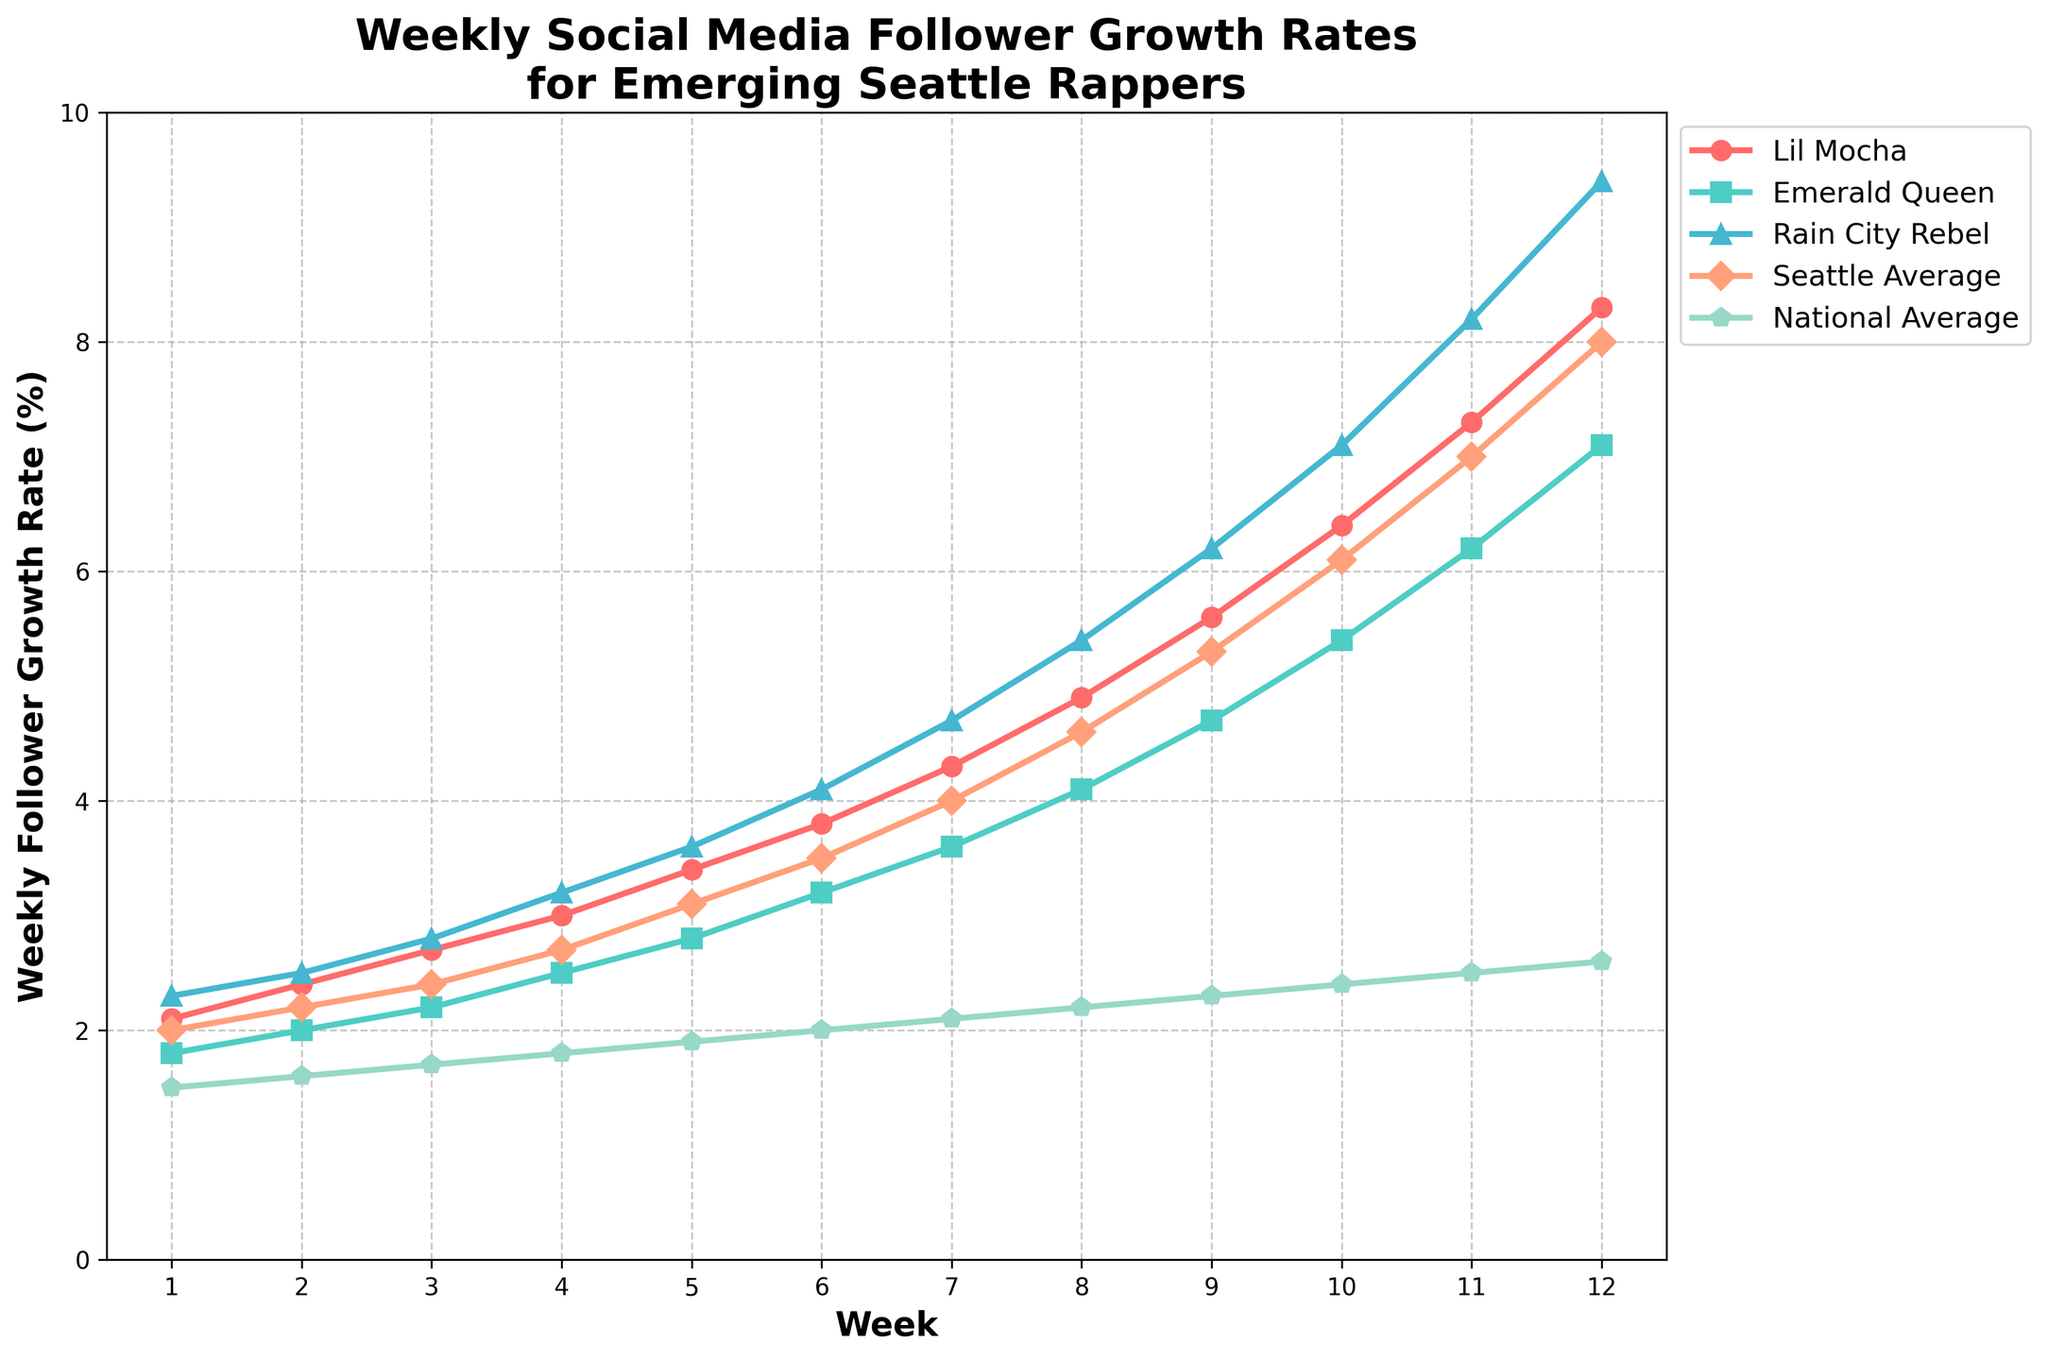How does the weekly follower growth rate of Lil Mocha compare to the Seattle Average in week 5? To answer this, locate week 5 on the x-axis and compare the y-values for Lil Mocha and Seattle Average. Lil Mocha has a growth rate of 3.4% and the Seattle Average is 3.1%.
Answer: Lil Mocha's rate is higher What is the trend of the National Average follower growth rate from week 1 to week 12? Observe the line representing the National Average from week 1 to week 12. The line shows a steady increase starting from 1.5% in week 1 to 2.6% in week 12.
Answer: Steadily increasing Which rapper has the highest follower growth rate in week 8? Look at week 8 on the x-axis and check the y-values of all rappers. Rain City Rebel reaches 5.4%, the highest in that week.
Answer: Rain City Rebel On what weeks does Rain City Rebel’s growth rate intersect with Emerald Queen’s growth rate? Identify where the line representing Rain City Rebel intersects with the line representing Emerald Queen. This occurs between weeks 1 to 12. The key intersections are around weeks 4 and 8.
Answer: Week 4 and Week 8 By how much did the Seattle Average follower growth rate increase from week 4 to week 12? Determine the Seattle Average growth rates in weeks 4 and 12, which are 2.7% and 8.0%, respectively, and subtract the former from the latter. 8.0% - 2.7% = 5.3%.
Answer: 5.3% Which rapper has the sharpest increase in their growth rates over the 12 weeks? Evaluate the slopes of the lines representing each rapper. Lil Mocha’s line steeply ascends from 2.1% to 8.3% over 12 weeks, which is the sharpest increase among all.
Answer: Lil Mocha Compare Lil Mocha’s follower growth rate to Rain City Rebel's in week 6. Look at week 6 on the x-axis and compare the y-values of Lil Mocha and Rain City Rebel. Lil Mocha's growth rate is 3.8% and Rain City Rebel's is 4.1%.
Answer: Lil Mocha's rate is lower In which week does Emerald Queen’s growth rate surpass 4.0%? Trace the line representing Emerald Queen and identify the week where it first exceeds the 4.0% mark on the y-axis. This happens in week 8.
Answer: Week 8 How does the follower growth rate of Rain City Rebel in week 10 compare to Emerald Queen in week 12? Observe the y-values for Rain City Rebel in week 10 (7.1%) and for Emerald Queen in week 12 (7.1%).
Answer: They are equal Which week shows the largest gap between the Seattle Average and the National Average growth rate? Calculate the difference between the Seattle Average and National Average for each week. The largest gap between these averages appears in week 12 where Seattle has 8.0% and the national has 2.6%.
Answer: Week 12 